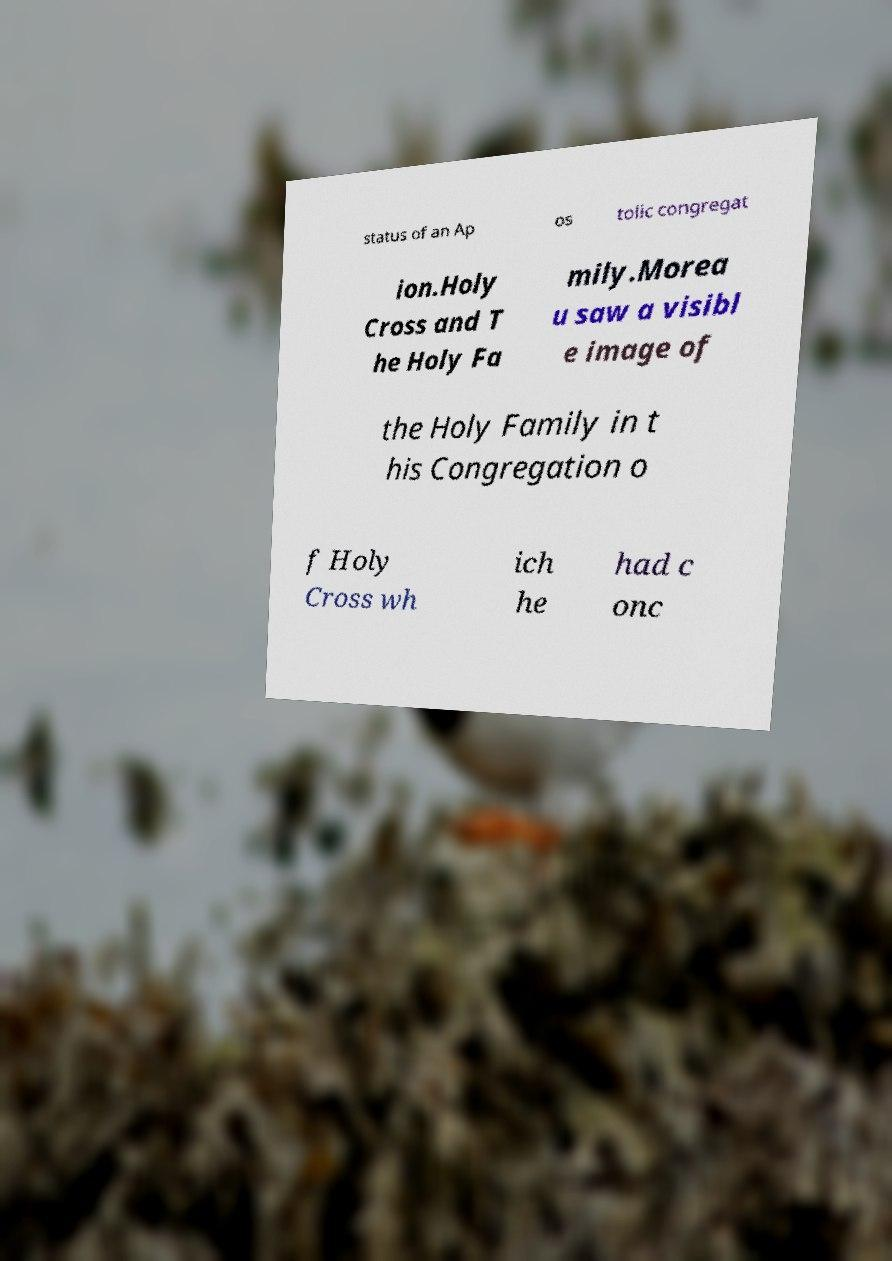Can you read and provide the text displayed in the image?This photo seems to have some interesting text. Can you extract and type it out for me? status of an Ap os tolic congregat ion.Holy Cross and T he Holy Fa mily.Morea u saw a visibl e image of the Holy Family in t his Congregation o f Holy Cross wh ich he had c onc 